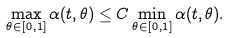Convert formula to latex. <formula><loc_0><loc_0><loc_500><loc_500>\max _ { \theta \in [ 0 , 1 ] } \alpha ( t , \theta ) \leq C \min _ { \theta \in [ 0 , 1 ] } \alpha ( t , \theta ) .</formula> 